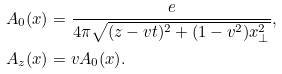Convert formula to latex. <formula><loc_0><loc_0><loc_500><loc_500>A _ { 0 } ( x ) & = \frac { e } { 4 \pi \sqrt { ( z - v t ) ^ { 2 } + ( 1 - v ^ { 2 } ) x _ { \bot } ^ { 2 } } } , \\ A _ { z } ( x ) & = v A _ { 0 } ( x ) .</formula> 